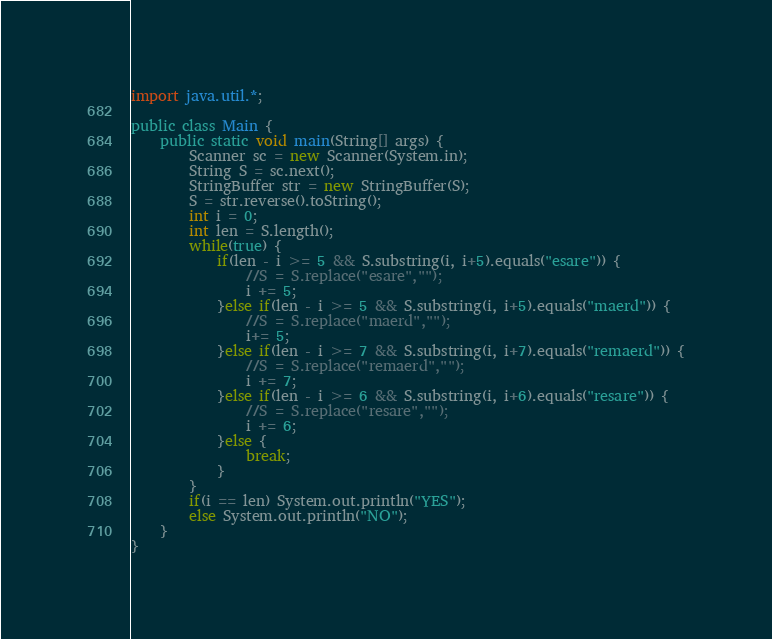Convert code to text. <code><loc_0><loc_0><loc_500><loc_500><_Java_>import java.util.*;
 
public class Main {
    public static void main(String[] args) {
        Scanner sc = new Scanner(System.in);
        String S = sc.next();
        StringBuffer str = new StringBuffer(S);
        S = str.reverse().toString();
        int i = 0;
        int len = S.length();
        while(true) {
            if(len - i >= 5 && S.substring(i, i+5).equals("esare")) {
                //S = S.replace("esare","");
                i += 5;
            }else if(len - i >= 5 && S.substring(i, i+5).equals("maerd")) {
                //S = S.replace("maerd","");
                i+= 5;
            }else if(len - i >= 7 && S.substring(i, i+7).equals("remaerd")) {
                //S = S.replace("remaerd","");
                i += 7;
            }else if(len - i >= 6 && S.substring(i, i+6).equals("resare")) {
                //S = S.replace("resare","");
                i += 6;
            }else {
                break;
            }
        }
        if(i == len) System.out.println("YES");
        else System.out.println("NO");
    }
}</code> 